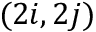<formula> <loc_0><loc_0><loc_500><loc_500>( 2 i , 2 j )</formula> 